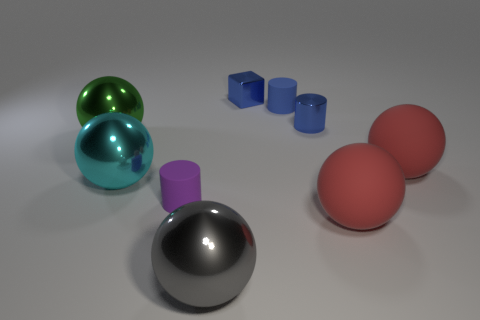Does the small metallic cylinder have the same color as the tiny block?
Provide a succinct answer. Yes. How many green things are right of the large red object that is behind the cyan metal sphere?
Offer a terse response. 0. What is the size of the thing that is both on the right side of the big cyan sphere and to the left of the gray object?
Your response must be concise. Small. Is the number of blue matte cylinders greater than the number of matte spheres?
Provide a succinct answer. No. Is there a metallic sphere of the same color as the tiny cube?
Provide a succinct answer. No. There is a cylinder that is on the left side of the shiny block; is it the same size as the tiny metallic cube?
Offer a very short reply. Yes. Is the number of cyan metal blocks less than the number of big red matte things?
Provide a short and direct response. Yes. Is there a cylinder made of the same material as the purple object?
Offer a very short reply. Yes. What is the shape of the big shiny object that is on the right side of the tiny purple rubber object?
Your answer should be compact. Sphere. Does the small matte cylinder right of the gray shiny sphere have the same color as the small metal block?
Your response must be concise. Yes. 